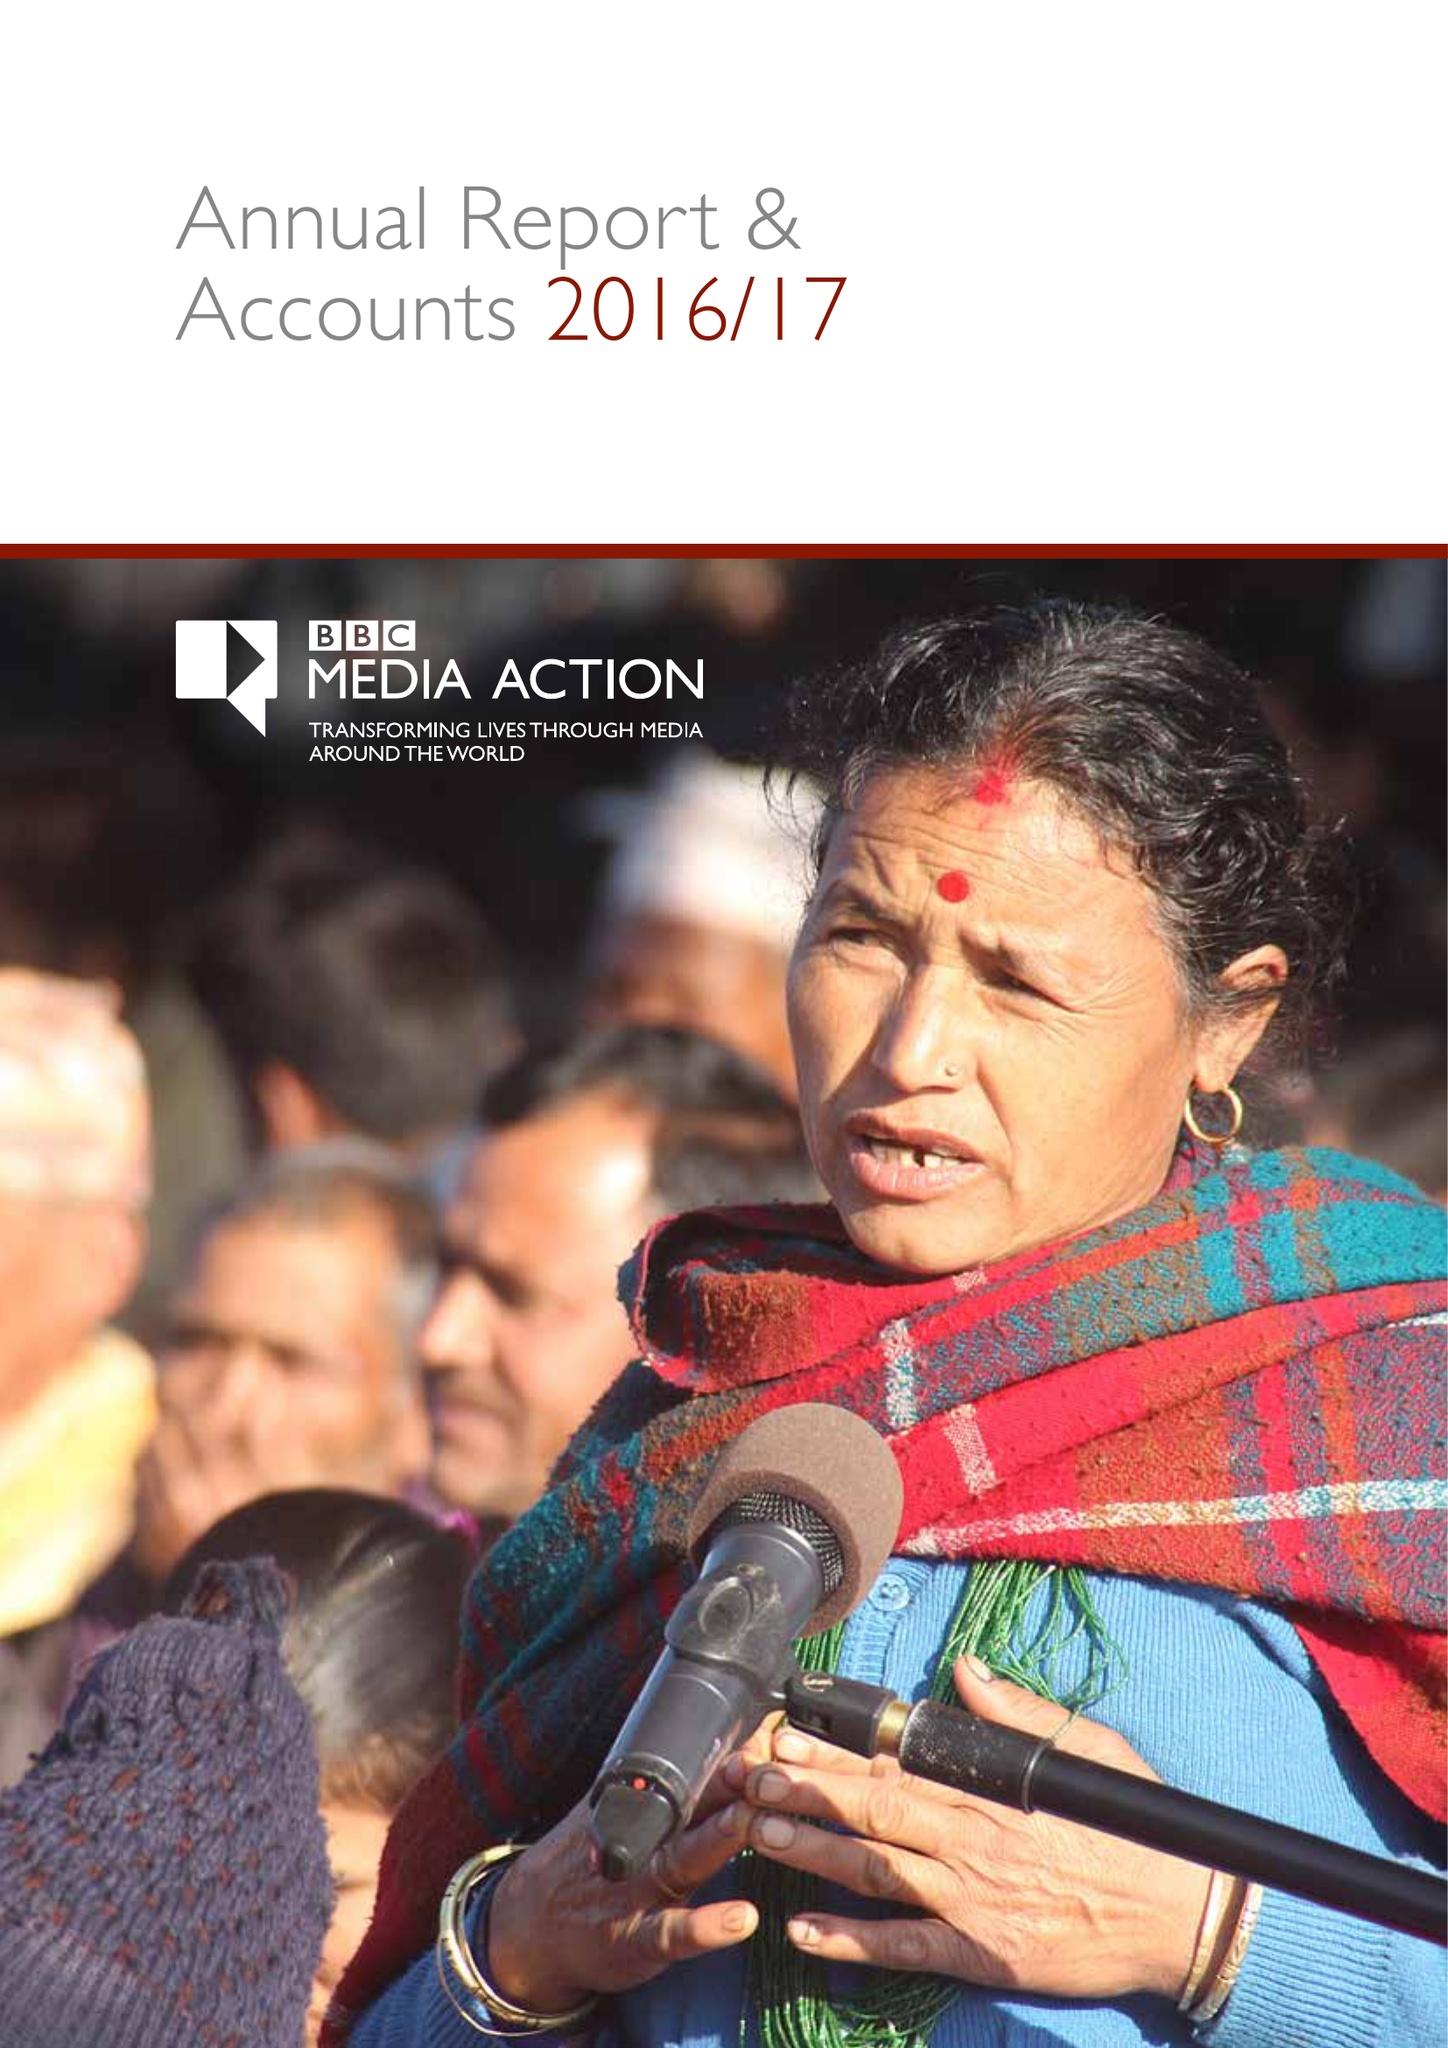What is the value for the income_annually_in_british_pounds?
Answer the question using a single word or phrase. 44151000.00 